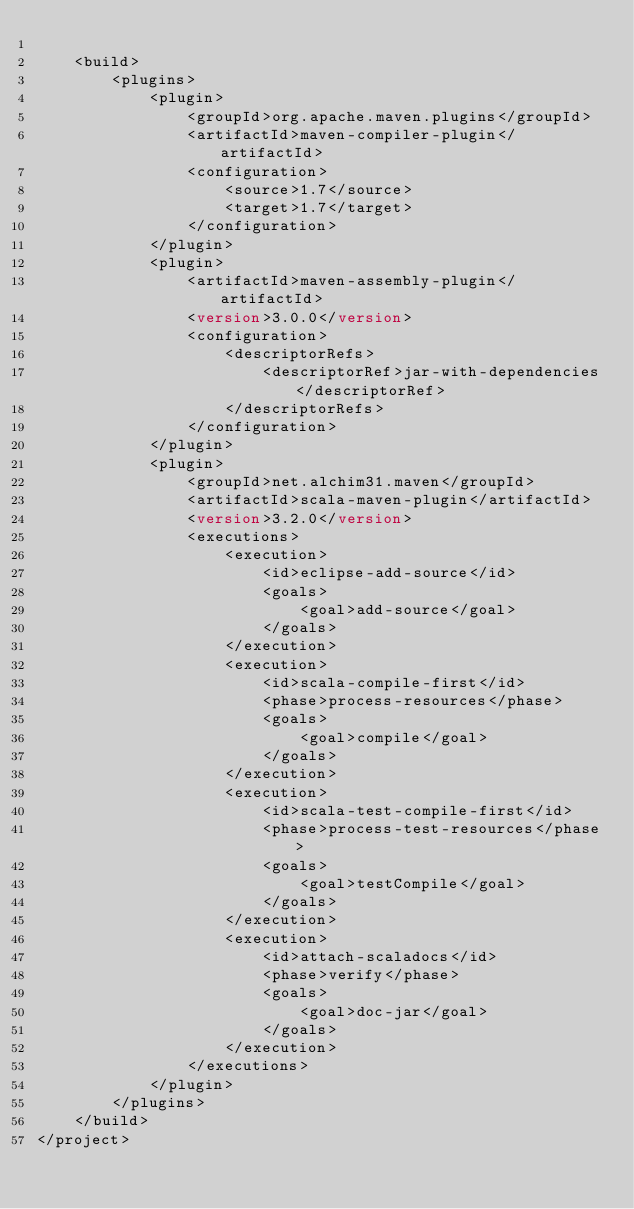Convert code to text. <code><loc_0><loc_0><loc_500><loc_500><_XML_>
    <build>
        <plugins>
            <plugin>
                <groupId>org.apache.maven.plugins</groupId>
                <artifactId>maven-compiler-plugin</artifactId>
                <configuration>
                    <source>1.7</source>
                    <target>1.7</target>
                </configuration>
            </plugin>
            <plugin>
                <artifactId>maven-assembly-plugin</artifactId>
                <version>3.0.0</version>
                <configuration>
                    <descriptorRefs>
                        <descriptorRef>jar-with-dependencies</descriptorRef>
                    </descriptorRefs>
                </configuration>
            </plugin>
            <plugin>
                <groupId>net.alchim31.maven</groupId>
                <artifactId>scala-maven-plugin</artifactId>
                <version>3.2.0</version>
                <executions>
                    <execution>
                        <id>eclipse-add-source</id>
                        <goals>
                            <goal>add-source</goal>
                        </goals>
                    </execution>
                    <execution>
                        <id>scala-compile-first</id>
                        <phase>process-resources</phase>
                        <goals>
                            <goal>compile</goal>
                        </goals>
                    </execution>
                    <execution>
                        <id>scala-test-compile-first</id>
                        <phase>process-test-resources</phase>
                        <goals>
                            <goal>testCompile</goal>
                        </goals>
                    </execution>
                    <execution>
                        <id>attach-scaladocs</id>
                        <phase>verify</phase>
                        <goals>
                            <goal>doc-jar</goal>
                        </goals>
                    </execution>
                </executions>
            </plugin>
        </plugins>
    </build>
</project>
</code> 